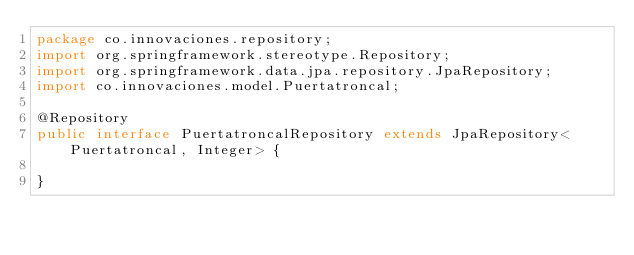Convert code to text. <code><loc_0><loc_0><loc_500><loc_500><_Java_>package co.innovaciones.repository;
import org.springframework.stereotype.Repository;
import org.springframework.data.jpa.repository.JpaRepository;
import co.innovaciones.model.Puertatroncal;

@Repository
public interface PuertatroncalRepository extends JpaRepository<Puertatroncal, Integer> {
	
}</code> 